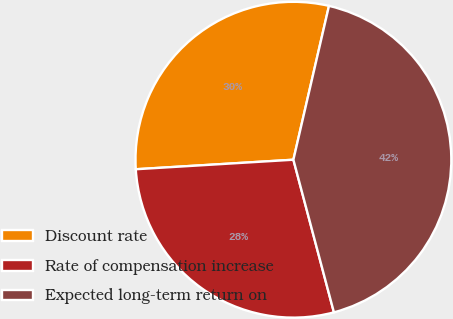<chart> <loc_0><loc_0><loc_500><loc_500><pie_chart><fcel>Discount rate<fcel>Rate of compensation increase<fcel>Expected long-term return on<nl><fcel>29.58%<fcel>28.17%<fcel>42.25%<nl></chart> 